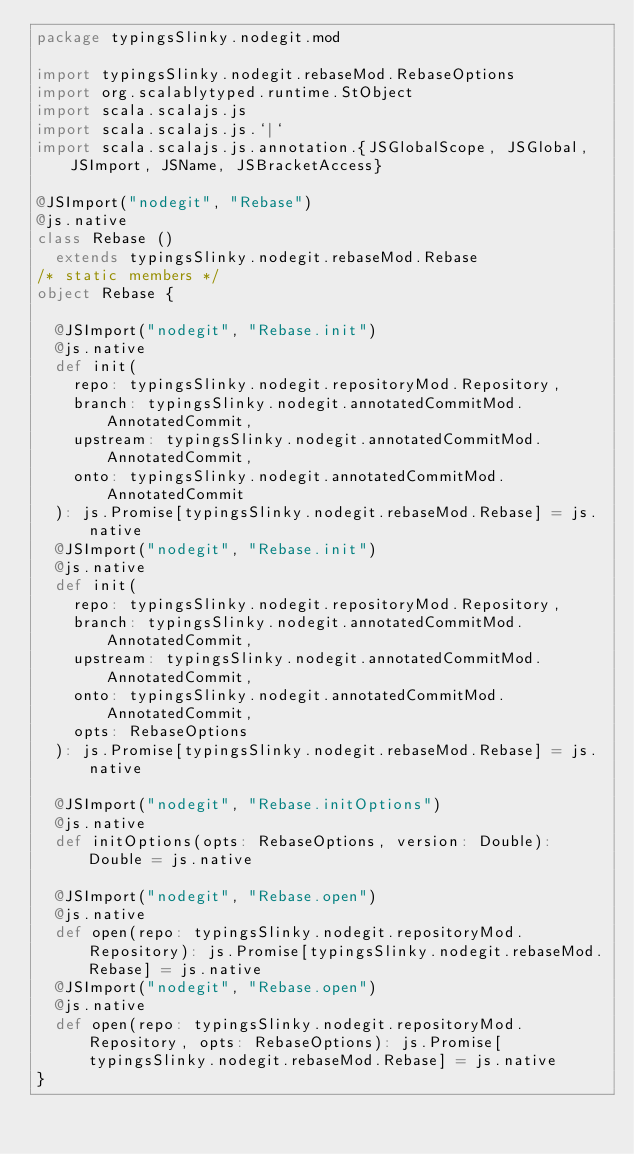<code> <loc_0><loc_0><loc_500><loc_500><_Scala_>package typingsSlinky.nodegit.mod

import typingsSlinky.nodegit.rebaseMod.RebaseOptions
import org.scalablytyped.runtime.StObject
import scala.scalajs.js
import scala.scalajs.js.`|`
import scala.scalajs.js.annotation.{JSGlobalScope, JSGlobal, JSImport, JSName, JSBracketAccess}

@JSImport("nodegit", "Rebase")
@js.native
class Rebase ()
  extends typingsSlinky.nodegit.rebaseMod.Rebase
/* static members */
object Rebase {
  
  @JSImport("nodegit", "Rebase.init")
  @js.native
  def init(
    repo: typingsSlinky.nodegit.repositoryMod.Repository,
    branch: typingsSlinky.nodegit.annotatedCommitMod.AnnotatedCommit,
    upstream: typingsSlinky.nodegit.annotatedCommitMod.AnnotatedCommit,
    onto: typingsSlinky.nodegit.annotatedCommitMod.AnnotatedCommit
  ): js.Promise[typingsSlinky.nodegit.rebaseMod.Rebase] = js.native
  @JSImport("nodegit", "Rebase.init")
  @js.native
  def init(
    repo: typingsSlinky.nodegit.repositoryMod.Repository,
    branch: typingsSlinky.nodegit.annotatedCommitMod.AnnotatedCommit,
    upstream: typingsSlinky.nodegit.annotatedCommitMod.AnnotatedCommit,
    onto: typingsSlinky.nodegit.annotatedCommitMod.AnnotatedCommit,
    opts: RebaseOptions
  ): js.Promise[typingsSlinky.nodegit.rebaseMod.Rebase] = js.native
  
  @JSImport("nodegit", "Rebase.initOptions")
  @js.native
  def initOptions(opts: RebaseOptions, version: Double): Double = js.native
  
  @JSImport("nodegit", "Rebase.open")
  @js.native
  def open(repo: typingsSlinky.nodegit.repositoryMod.Repository): js.Promise[typingsSlinky.nodegit.rebaseMod.Rebase] = js.native
  @JSImport("nodegit", "Rebase.open")
  @js.native
  def open(repo: typingsSlinky.nodegit.repositoryMod.Repository, opts: RebaseOptions): js.Promise[typingsSlinky.nodegit.rebaseMod.Rebase] = js.native
}
</code> 